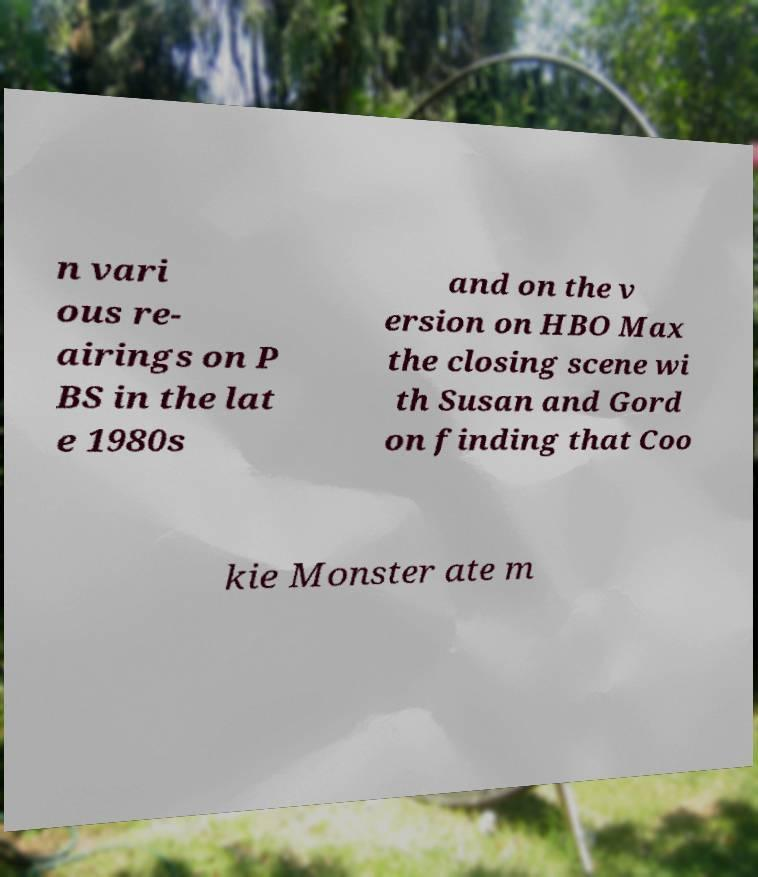Could you extract and type out the text from this image? n vari ous re- airings on P BS in the lat e 1980s and on the v ersion on HBO Max the closing scene wi th Susan and Gord on finding that Coo kie Monster ate m 